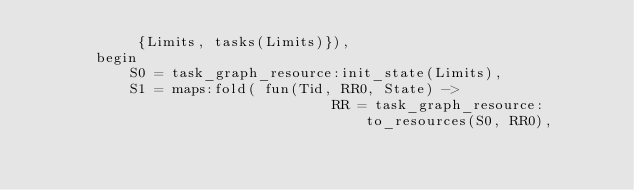Convert code to text. <code><loc_0><loc_0><loc_500><loc_500><_Erlang_>            {Limits, tasks(Limits)}),
       begin
           S0 = task_graph_resource:init_state(Limits),
           S1 = maps:fold( fun(Tid, RR0, State) ->
                                   RR = task_graph_resource:to_resources(S0, RR0),</code> 